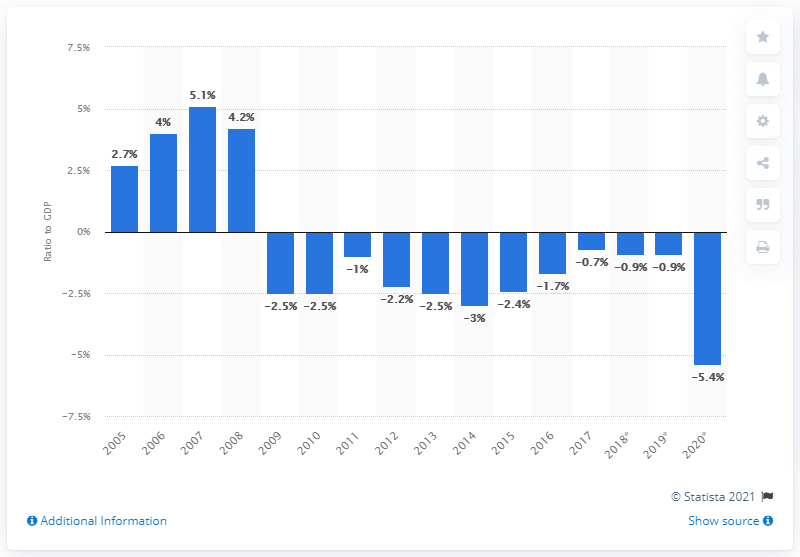Outline some significant characteristics in this image. In the year 2009, Finland's government budget remained clearly in deficit. 